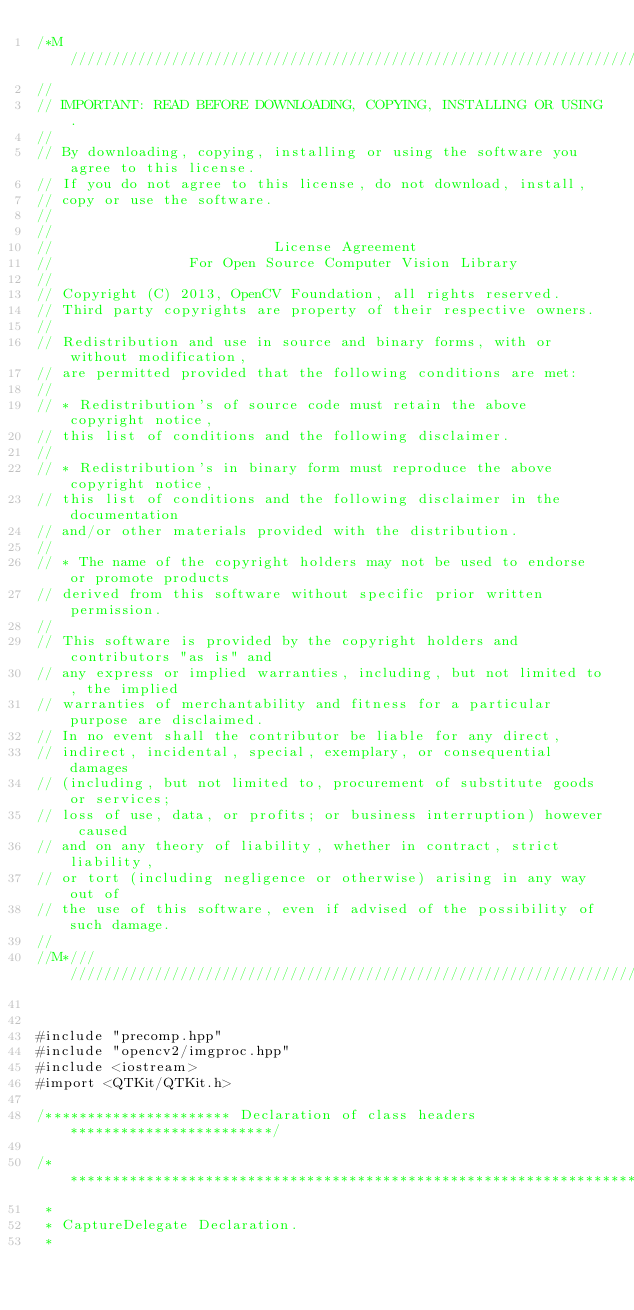<code> <loc_0><loc_0><loc_500><loc_500><_ObjectiveC_>/*M///////////////////////////////////////////////////////////////////////////////////////
//
// IMPORTANT: READ BEFORE DOWNLOADING, COPYING, INSTALLING OR USING.
//
// By downloading, copying, installing or using the software you agree to this license.
// If you do not agree to this license, do not download, install,
// copy or use the software.
//
//
//                          License Agreement
//                For Open Source Computer Vision Library
//
// Copyright (C) 2013, OpenCV Foundation, all rights reserved.
// Third party copyrights are property of their respective owners.
//
// Redistribution and use in source and binary forms, with or without modification,
// are permitted provided that the following conditions are met:
//
// * Redistribution's of source code must retain the above copyright notice,
// this list of conditions and the following disclaimer.
//
// * Redistribution's in binary form must reproduce the above copyright notice,
// this list of conditions and the following disclaimer in the documentation
// and/or other materials provided with the distribution.
//
// * The name of the copyright holders may not be used to endorse or promote products
// derived from this software without specific prior written permission.
//
// This software is provided by the copyright holders and contributors "as is" and
// any express or implied warranties, including, but not limited to, the implied
// warranties of merchantability and fitness for a particular purpose are disclaimed.
// In no event shall the contributor be liable for any direct,
// indirect, incidental, special, exemplary, or consequential damages
// (including, but not limited to, procurement of substitute goods or services;
// loss of use, data, or profits; or business interruption) however caused
// and on any theory of liability, whether in contract, strict liability,
// or tort (including negligence or otherwise) arising in any way out of
// the use of this software, even if advised of the possibility of such damage.
//
//M*////////////////////////////////////////////////////////////////////////////////////////


#include "precomp.hpp"
#include "opencv2/imgproc.hpp"
#include <iostream>
#import <QTKit/QTKit.h>

/********************** Declaration of class headers ************************/

/*****************************************************************************
 *
 * CaptureDelegate Declaration.
 *</code> 